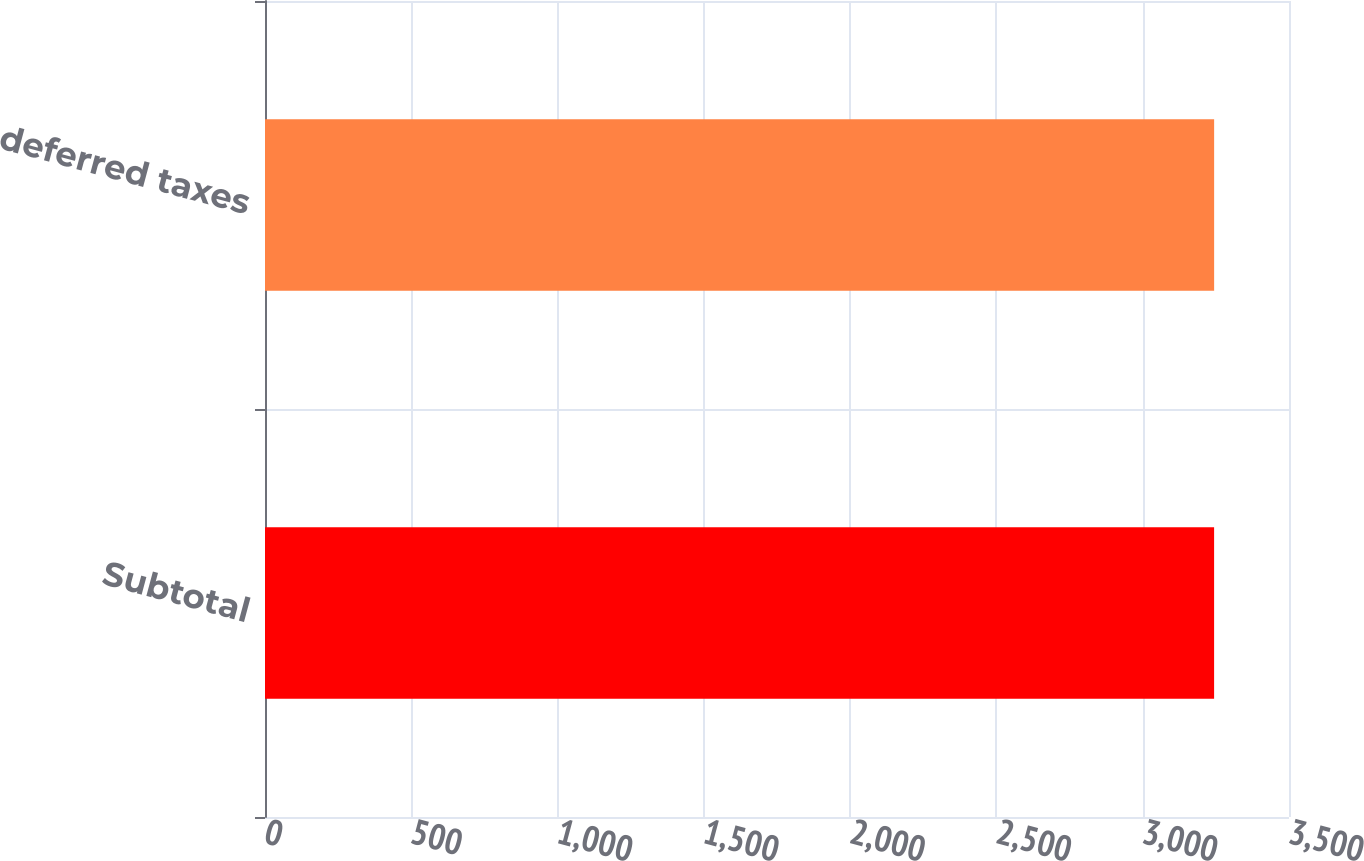Convert chart to OTSL. <chart><loc_0><loc_0><loc_500><loc_500><bar_chart><fcel>Subtotal<fcel>Total deferred taxes<nl><fcel>3244<fcel>3244.1<nl></chart> 